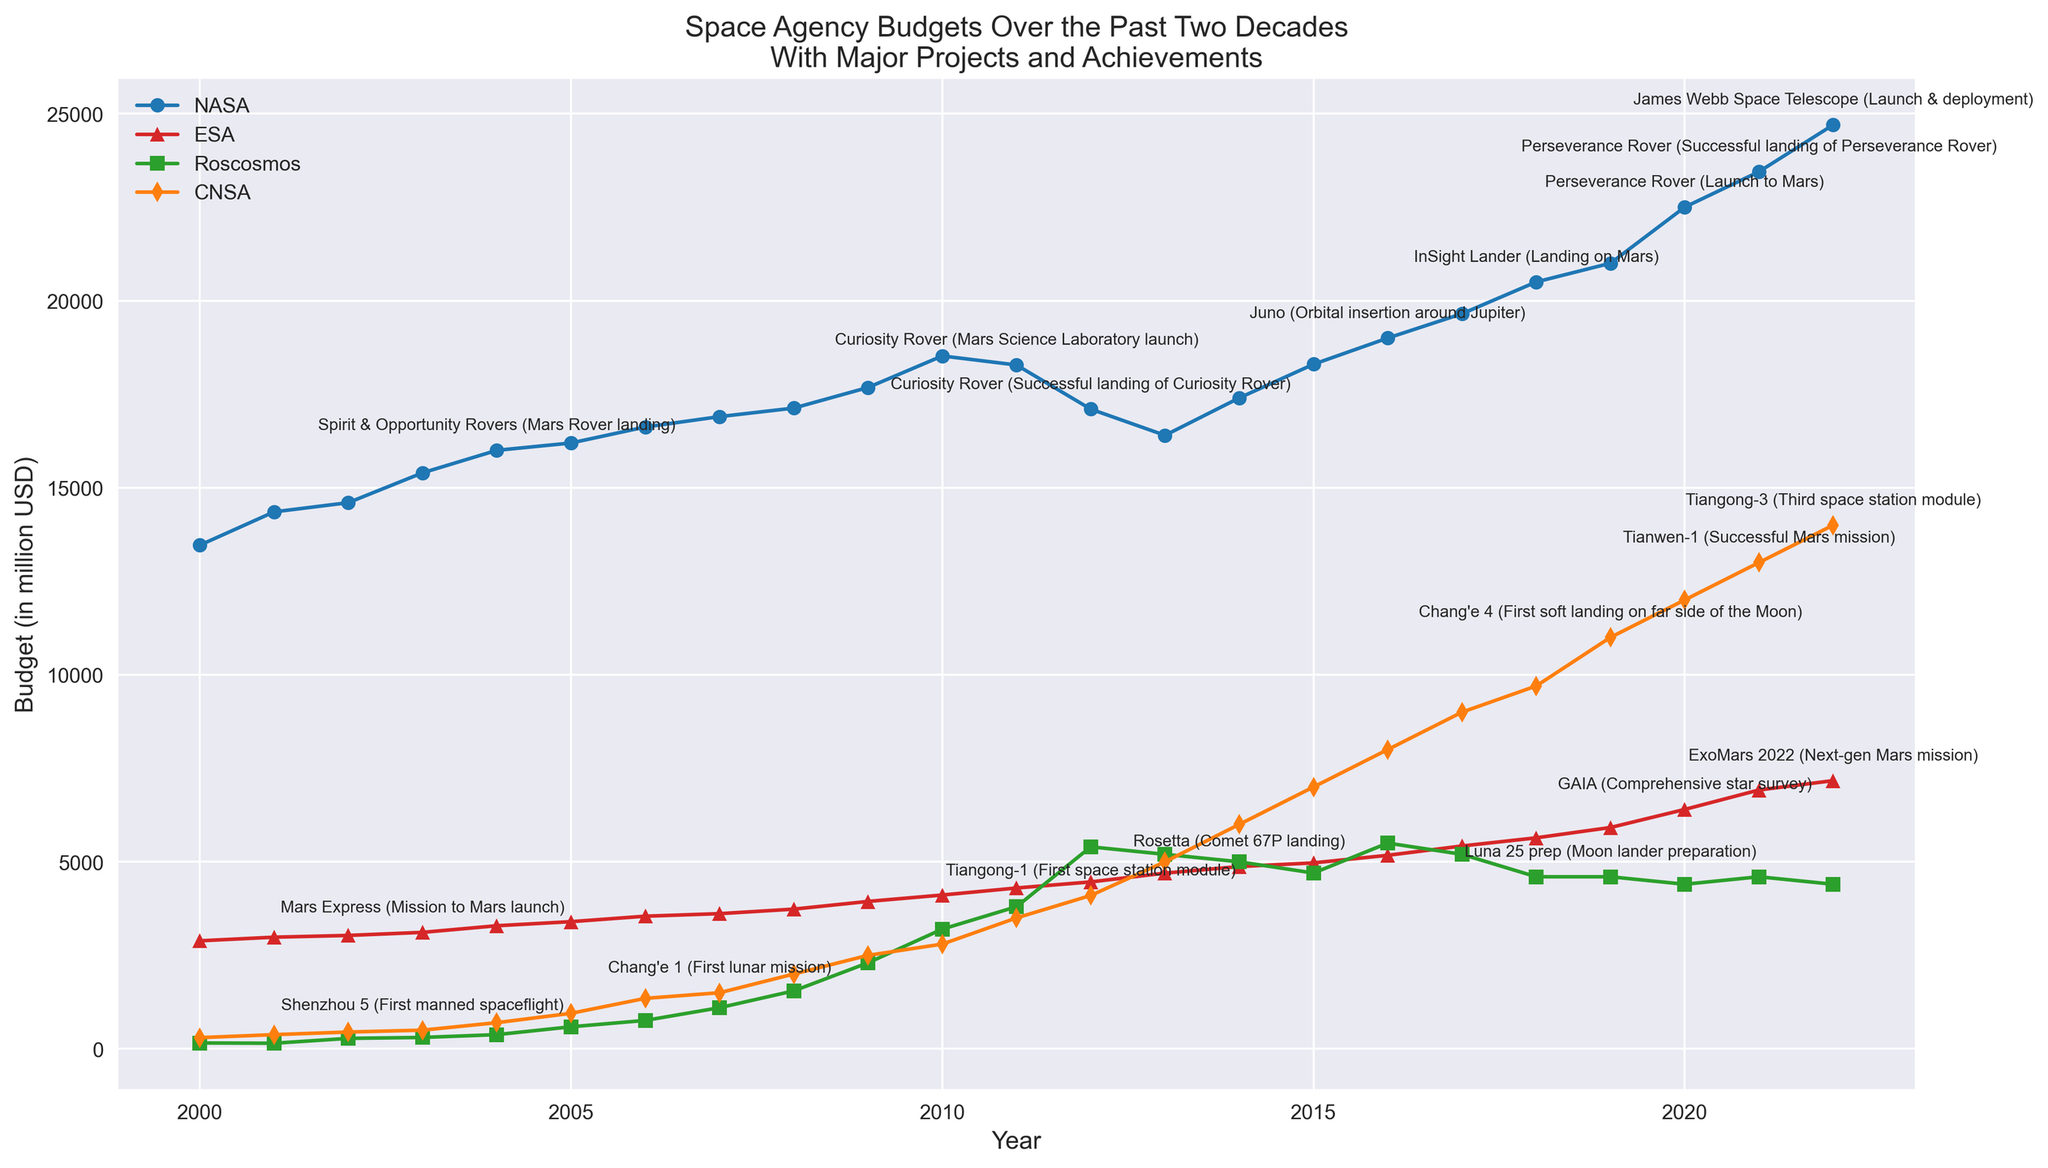What was NASA's budget in the years with the major projects listed? The years with major projects listed for NASA are 2004, 2011, 2012, 2016, 2018, 2020, 2021, and 2022. The corresponding budgets are: 2004 - $15,999 million, 2011 - $18,280 million, 2012 - $17,100 million, 2016 - $19,000 million, 2018 - $20,500 million, 2020 - $22,500 million, 2021 - $23,447 million, 2022 - $24,700 million
Answer: 2004: $15999M, 2011: $18280M, 2012: $17100M, 2016: $19000M, 2018: $20500M, 2020: $22500M, 2021: $23447M, 2022: $24700M Which agency had the highest budget in 2022? To determine the agency with the highest budget in 2022, compare the budgets: NASA - $24,700 million, ESA - $7,170 million, Roscosmos - $4,400 million, CNSA - $14,000 million. NASA has the highest budget.
Answer: NASA Compare the budget trends of Roscosmos and CNSA over the observed period. Which one consistently had higher budgets? Over the observed period, CNSA had a consistently higher budget compared to Roscosmos. Notably, starting from around 2010 and onwards, CNSA's budget sees a significant increase, whereas Roscosmos' budget remains relatively lower and more erratic.
Answer: CNSA Which major project event occurred with the lowest budget for its agency and what was the budget? The major project with the lowest budget is "Shenzhou 5 (First manned spaceflight)" by CNSA in 2003 with a budget of $500 million.
Answer: Shenzhou 5, $500 million Identify the year when ESA made the Philae landing on a comet and its budget for that year. According to the annotations, ESA made the Philae landing on a comet in 2004 with a budget of $3,291 million.
Answer: 2004, $3291 million What was the budget difference between NASA and ESA in 2021? The budgets for NASA and ESA in 2021 are $23,447 million and $6,920 million respectively. The difference is $23,447M - $6,920M = $16,527 million.
Answer: $16527 million Which agency had the most significant budget increase over a single year, based on the trend lines shown? By analyzing the trend lines, the most significant budget increase over a single year was seen in CNSA around 2009 to 2010, where the budget jumped from $2,500 million to $2,800 million—a $300 million increase. However, for most substantial, Roscosmos increased by $800 million from 2008 to 2009 (from $1,550 million to $2,300 million).
Answer: Roscosmos Compare the major projects undertaken by ESA and identify the one associated with the highest budget. ESA's major projects are Mars Express (2003), Philae landing on comet (2004), Rosetta (2014), GAIA (2020), ExoMars 2022 (2022). The highest budget year among these is 2022, with a budget of $7,170 million for ExoMars 2022.
Answer: ExoMars 2022, $7170 million 